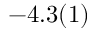<formula> <loc_0><loc_0><loc_500><loc_500>- 4 . 3 ( 1 )</formula> 